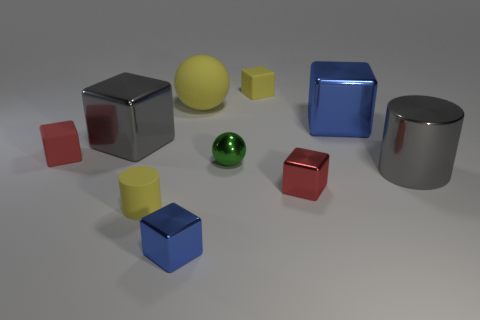Does the big matte thing have the same color as the matte cylinder?
Offer a terse response. Yes. What is the size of the matte cylinder that is the same color as the big rubber ball?
Provide a short and direct response. Small. There is a small thing that is the same color as the tiny cylinder; what shape is it?
Your response must be concise. Cube. What is the color of the other small metallic thing that is the same shape as the small blue object?
Give a very brief answer. Red. Are there any other things of the same color as the large ball?
Provide a succinct answer. Yes. There is a blue thing that is behind the large gray metal cylinder; does it have the same size as the matte cube left of the big yellow matte thing?
Keep it short and to the point. No. Is the number of large objects right of the green metallic thing the same as the number of small green metallic spheres that are behind the large matte sphere?
Provide a succinct answer. No. There is a gray metallic cylinder; is it the same size as the metallic thing that is in front of the tiny red shiny block?
Offer a very short reply. No. There is a blue cube in front of the small red rubber thing; are there any things in front of it?
Keep it short and to the point. No. Are there any small purple metallic things of the same shape as the tiny blue metallic thing?
Keep it short and to the point. No. 